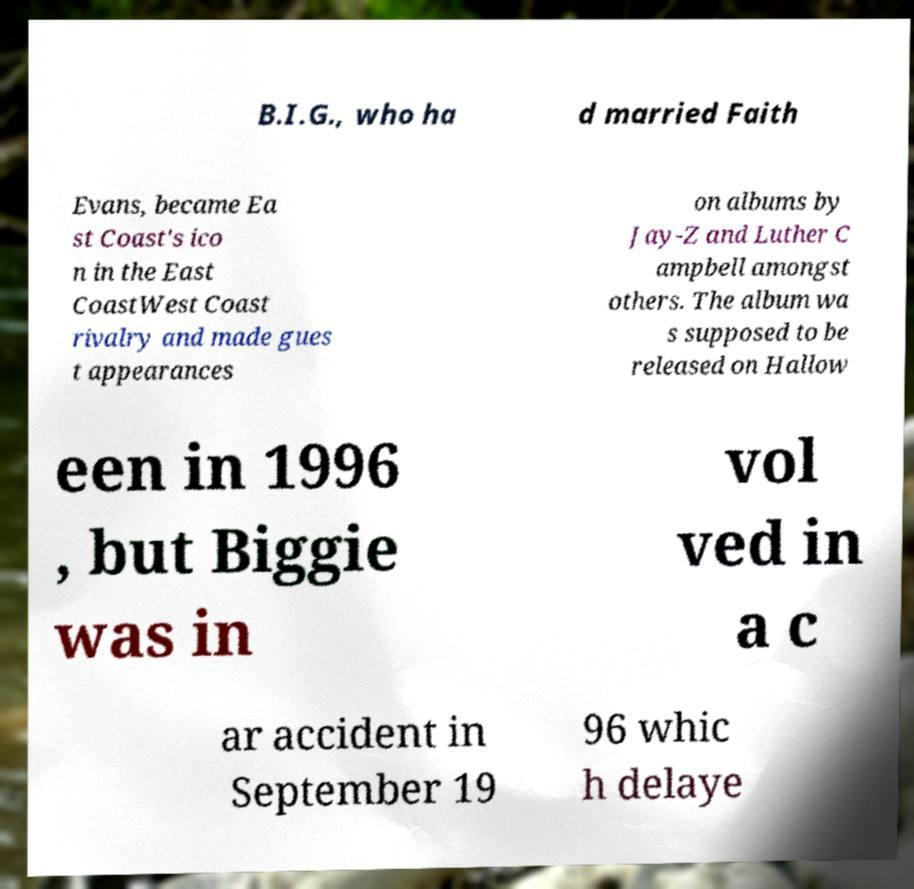Could you assist in decoding the text presented in this image and type it out clearly? B.I.G., who ha d married Faith Evans, became Ea st Coast's ico n in the East CoastWest Coast rivalry and made gues t appearances on albums by Jay-Z and Luther C ampbell amongst others. The album wa s supposed to be released on Hallow een in 1996 , but Biggie was in vol ved in a c ar accident in September 19 96 whic h delaye 